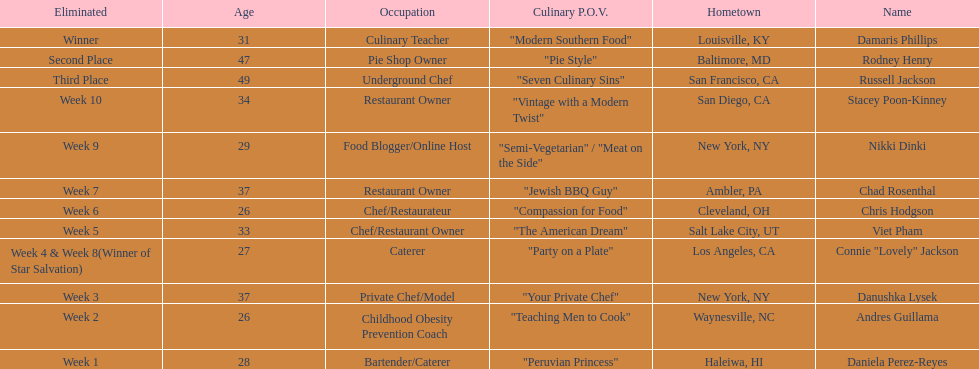How many competitors were under the age of 30? 5. 